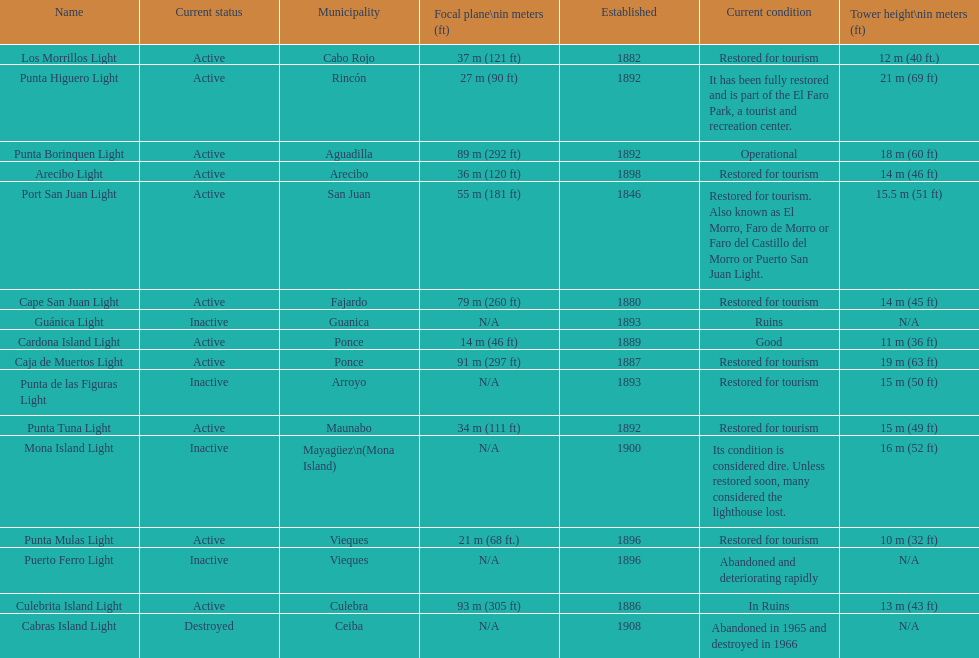How many establishments are restored for tourism? 9. 